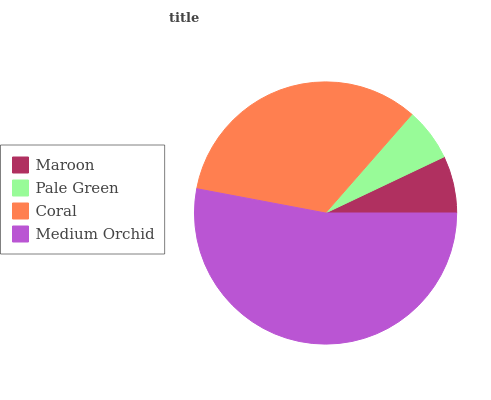Is Pale Green the minimum?
Answer yes or no. Yes. Is Medium Orchid the maximum?
Answer yes or no. Yes. Is Coral the minimum?
Answer yes or no. No. Is Coral the maximum?
Answer yes or no. No. Is Coral greater than Pale Green?
Answer yes or no. Yes. Is Pale Green less than Coral?
Answer yes or no. Yes. Is Pale Green greater than Coral?
Answer yes or no. No. Is Coral less than Pale Green?
Answer yes or no. No. Is Coral the high median?
Answer yes or no. Yes. Is Maroon the low median?
Answer yes or no. Yes. Is Maroon the high median?
Answer yes or no. No. Is Pale Green the low median?
Answer yes or no. No. 